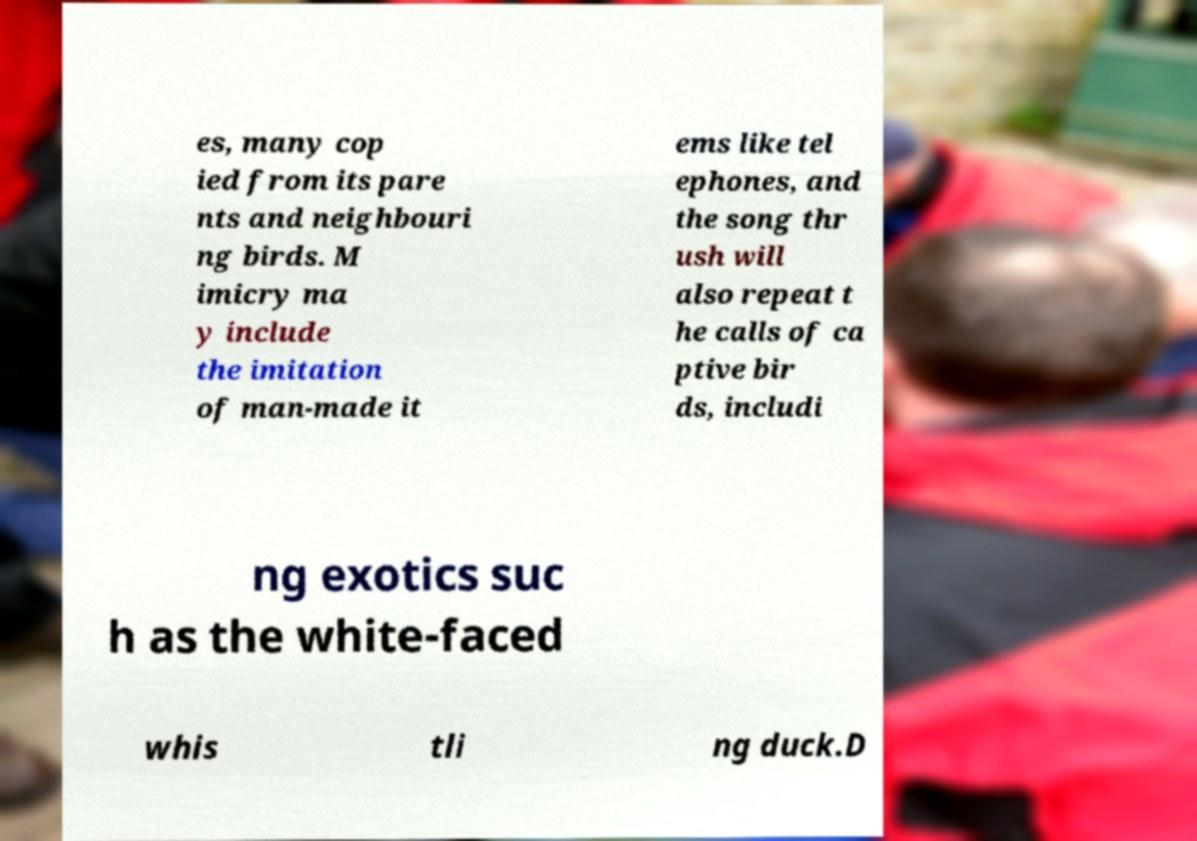Could you assist in decoding the text presented in this image and type it out clearly? es, many cop ied from its pare nts and neighbouri ng birds. M imicry ma y include the imitation of man-made it ems like tel ephones, and the song thr ush will also repeat t he calls of ca ptive bir ds, includi ng exotics suc h as the white-faced whis tli ng duck.D 